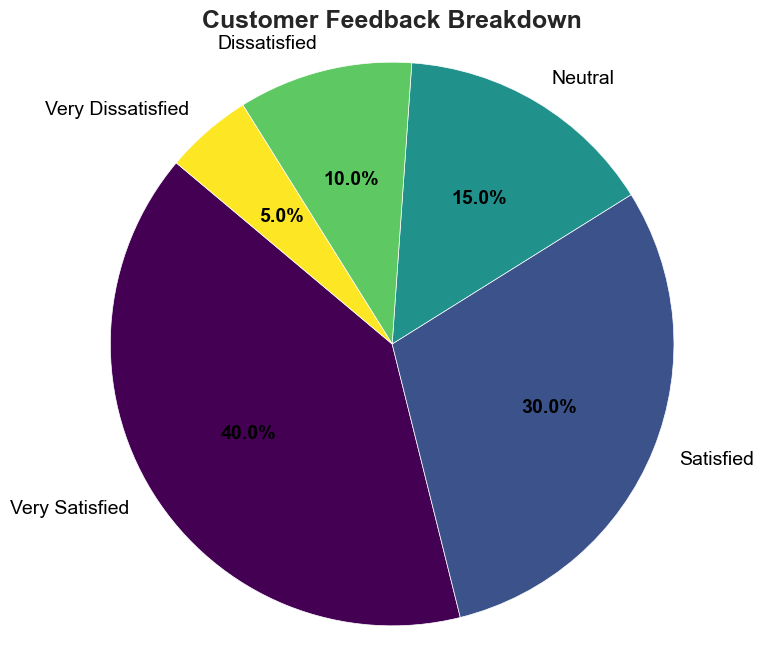What is the percentage of customers who are either dissatisfied or very dissatisfied? To find the percentage of customers who are either dissatisfied or very dissatisfied, sum the percentages of the 'Dissatisfied' and 'Very Dissatisfied' categories. That is, 10% (Dissatisfied) + 5% (Very Dissatisfied) = 15%.
Answer: 15% Which feedback type has the highest percentage? By examining the chart, we can see that the 'Very Satisfied' category has the largest segment, which represents 40% of the total.
Answer: Very Satisfied How does the percentage of 'Satisfied' customers compare to 'Neutral' customers? By looking at the chart, the 'Satisfied' category is 30%, which is greater than the 'Neutral' category's 15%. Therefore, 'Satisfied' customers represent double the percentage of 'Neutral' customers.
Answer: Satisfied has a higher percentage than Neutral What is the combined percentage of 'Very Satisfied' and 'Satisfied' customers? To find the combined percentage, add the percentages of 'Very Satisfied' and 'Satisfied' categories. That is, 40% (Very Satisfied) + 30% (Satisfied) = 70%.
Answer: 70% How many times larger is the 'Very Satisfied' segment compared to the 'Very Dissatisfied' segment? The 'Very Satisfied' segment is 40%, and the 'Very Dissatisfied' segment is 5%. To find out how many times larger, divide 40% by 5%, which equals 8. Thus, the 'Very Satisfied' segment is 8 times larger.
Answer: 8 times Which segments combined represent exactly 75% of the feedback? Summing the percentages of 'Very Satisfied' (40%), 'Satisfied' (30%), and 'Neutral' (15%) categories, we get 40% + 30% + 15% = 85%. We need exactly 75%; hence, 'Very Satisfied' (40%) + 'Satisfied' (30%) + 'Dissatisfied' (10%) instead sums up to 40% + 30% + 10% = 80%, which is closest to 75%, but still not an exact fit.
Answer: None combined equals exactly 75% If the percentage of 'Neutral' feedback were to increase by 5 percentage points, which category would it equal in percentage? If 'Neutral' feedback increases from 15% to 20% (15% + 5%), it would equal the 'Dissatisfied' category, which is currently 10%.
Answer: Neutral would equal Dissatisfied 